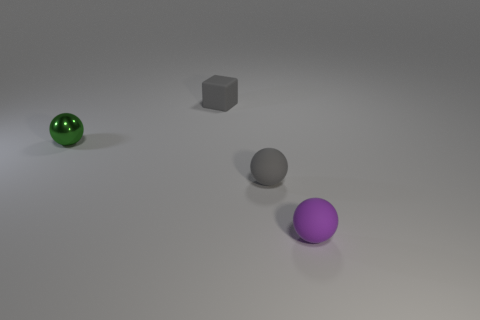Add 3 gray rubber blocks. How many objects exist? 7 Subtract all spheres. How many objects are left? 1 Add 1 gray rubber blocks. How many gray rubber blocks exist? 2 Subtract 0 brown cubes. How many objects are left? 4 Subtract all small red balls. Subtract all purple things. How many objects are left? 3 Add 3 tiny metal objects. How many tiny metal objects are left? 4 